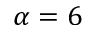Convert formula to latex. <formula><loc_0><loc_0><loc_500><loc_500>\alpha = 6</formula> 